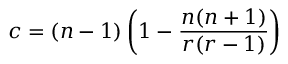<formula> <loc_0><loc_0><loc_500><loc_500>c = ( n - 1 ) \left ( 1 - \frac { n ( n + 1 ) } { r ( r - 1 ) } \right )</formula> 